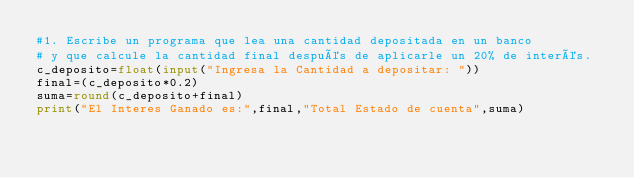Convert code to text. <code><loc_0><loc_0><loc_500><loc_500><_Python_>#1.	Escribe un programa que lea una cantidad depositada en un banco 
# y que calcule la cantidad final después de aplicarle un 20% de interés.
c_deposito=float(input("Ingresa la Cantidad a depositar: "))
final=(c_deposito*0.2)
suma=round(c_deposito+final)
print("El Interes Ganado es:",final,"Total Estado de cuenta",suma)

</code> 